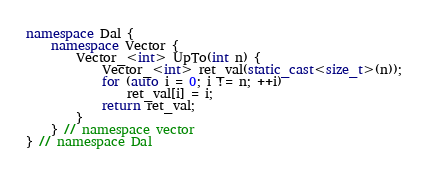<code> <loc_0><loc_0><loc_500><loc_500><_C++_>
namespace Dal {
    namespace Vector {
        Vector_<int> UpTo(int n) {
            Vector_<int> ret_val(static_cast<size_t>(n));
            for (auto i = 0; i != n; ++i)
                ret_val[i] = i;
            return ret_val;
        }
    } // namespace vector
} // namespace Dal
</code> 